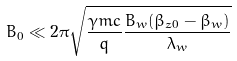<formula> <loc_0><loc_0><loc_500><loc_500>B _ { 0 } \ll 2 \pi \sqrt { \frac { \gamma m c } { q } \frac { B _ { w } ( \beta _ { z 0 } - \beta _ { w } ) } { \lambda _ { w } } }</formula> 